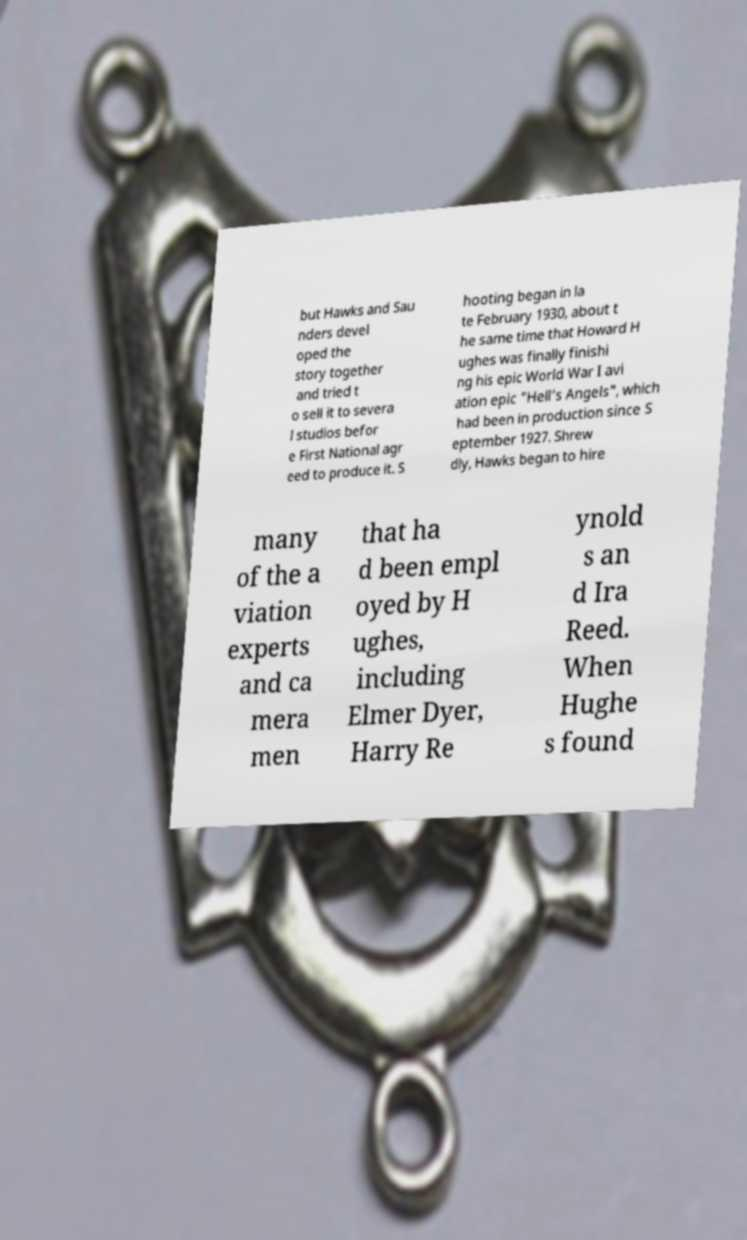Please read and relay the text visible in this image. What does it say? but Hawks and Sau nders devel oped the story together and tried t o sell it to severa l studios befor e First National agr eed to produce it. S hooting began in la te February 1930, about t he same time that Howard H ughes was finally finishi ng his epic World War I avi ation epic "Hell's Angels", which had been in production since S eptember 1927. Shrew dly, Hawks began to hire many of the a viation experts and ca mera men that ha d been empl oyed by H ughes, including Elmer Dyer, Harry Re ynold s an d Ira Reed. When Hughe s found 